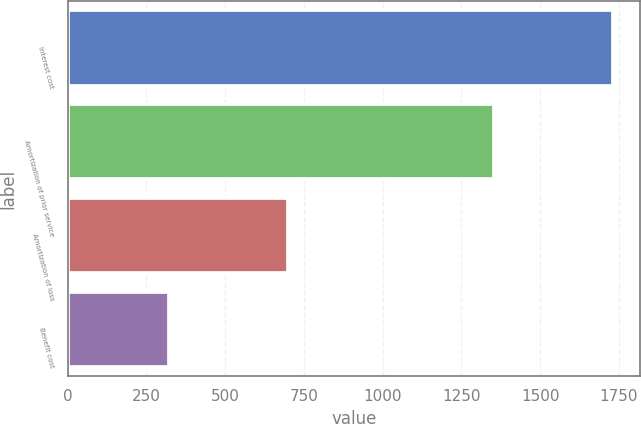Convert chart to OTSL. <chart><loc_0><loc_0><loc_500><loc_500><bar_chart><fcel>Interest cost<fcel>Amortization of prior service<fcel>Amortization of loss<fcel>Benefit cost<nl><fcel>1731<fcel>1353<fcel>699<fcel>321<nl></chart> 